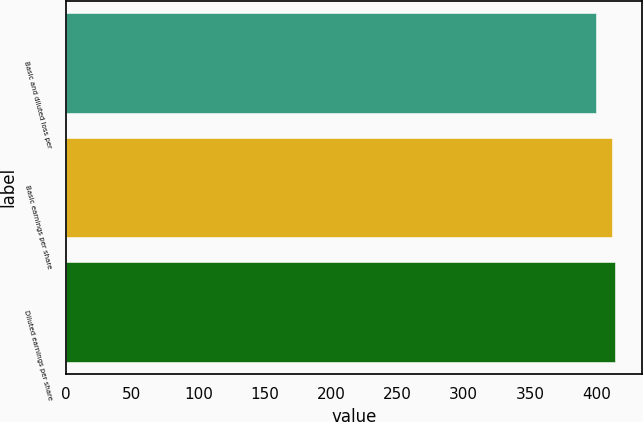<chart> <loc_0><loc_0><loc_500><loc_500><bar_chart><fcel>Basic and diluted loss per<fcel>Basic earnings per share<fcel>Diluted earnings per share<nl><fcel>400<fcel>412<fcel>414<nl></chart> 